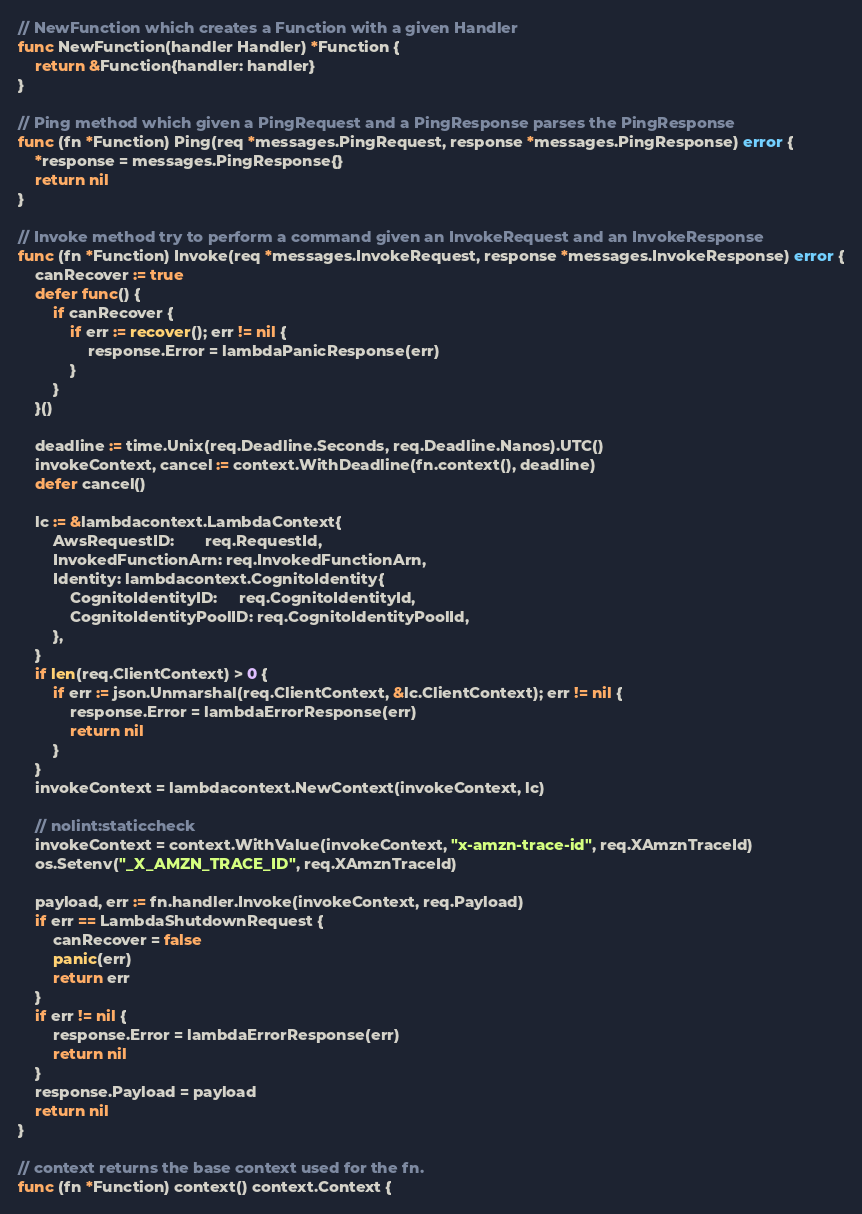Convert code to text. <code><loc_0><loc_0><loc_500><loc_500><_Go_>
// NewFunction which creates a Function with a given Handler
func NewFunction(handler Handler) *Function {
	return &Function{handler: handler}
}

// Ping method which given a PingRequest and a PingResponse parses the PingResponse
func (fn *Function) Ping(req *messages.PingRequest, response *messages.PingResponse) error {
	*response = messages.PingResponse{}
	return nil
}

// Invoke method try to perform a command given an InvokeRequest and an InvokeResponse
func (fn *Function) Invoke(req *messages.InvokeRequest, response *messages.InvokeResponse) error {
	canRecover := true
	defer func() {
		if canRecover {
			if err := recover(); err != nil {
				response.Error = lambdaPanicResponse(err)
			}
		}
	}()

	deadline := time.Unix(req.Deadline.Seconds, req.Deadline.Nanos).UTC()
	invokeContext, cancel := context.WithDeadline(fn.context(), deadline)
	defer cancel()

	lc := &lambdacontext.LambdaContext{
		AwsRequestID:       req.RequestId,
		InvokedFunctionArn: req.InvokedFunctionArn,
		Identity: lambdacontext.CognitoIdentity{
			CognitoIdentityID:     req.CognitoIdentityId,
			CognitoIdentityPoolID: req.CognitoIdentityPoolId,
		},
	}
	if len(req.ClientContext) > 0 {
		if err := json.Unmarshal(req.ClientContext, &lc.ClientContext); err != nil {
			response.Error = lambdaErrorResponse(err)
			return nil
		}
	}
	invokeContext = lambdacontext.NewContext(invokeContext, lc)

	// nolint:staticcheck
	invokeContext = context.WithValue(invokeContext, "x-amzn-trace-id", req.XAmznTraceId)
	os.Setenv("_X_AMZN_TRACE_ID", req.XAmznTraceId)

	payload, err := fn.handler.Invoke(invokeContext, req.Payload)
	if err == LambdaShutdownRequest {
		canRecover = false
		panic(err)
		return err
	}
	if err != nil {
		response.Error = lambdaErrorResponse(err)
		return nil
	}
	response.Payload = payload
	return nil
}

// context returns the base context used for the fn.
func (fn *Function) context() context.Context {</code> 